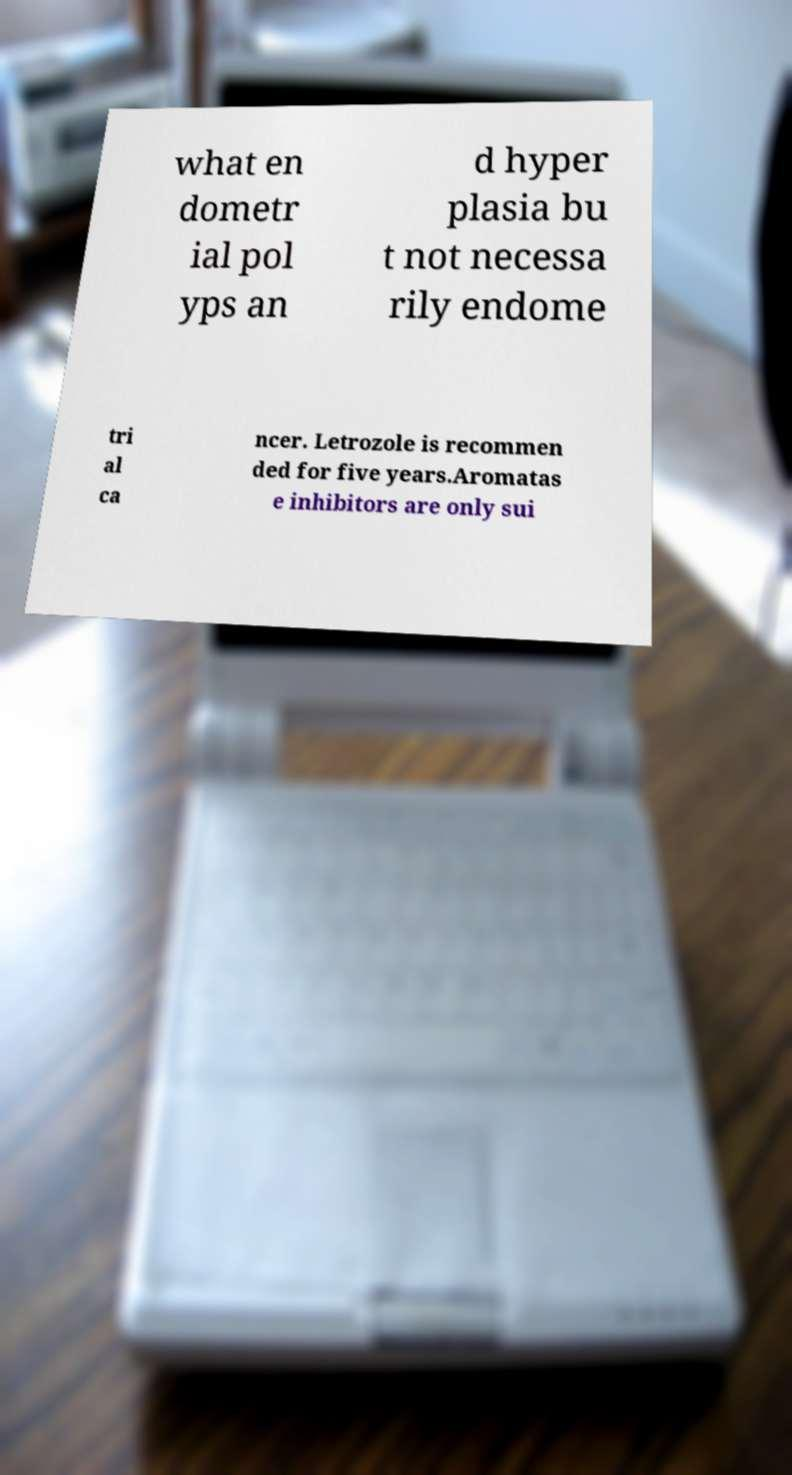Please read and relay the text visible in this image. What does it say? what en dometr ial pol yps an d hyper plasia bu t not necessa rily endome tri al ca ncer. Letrozole is recommen ded for five years.Aromatas e inhibitors are only sui 